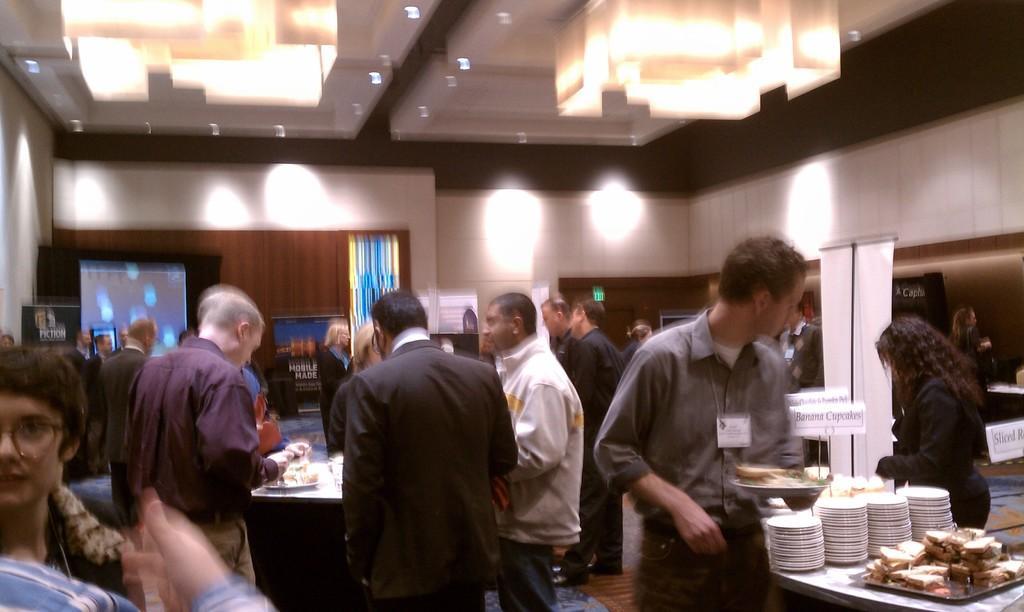In one or two sentences, can you explain what this image depicts? In this image we can see people standing on the floor and some of them are holding serving plates in their hands, tables with serving plates with food in them and arranged in the rows, electric lights, chandeliers, display screen, sign boards and advertisements. 